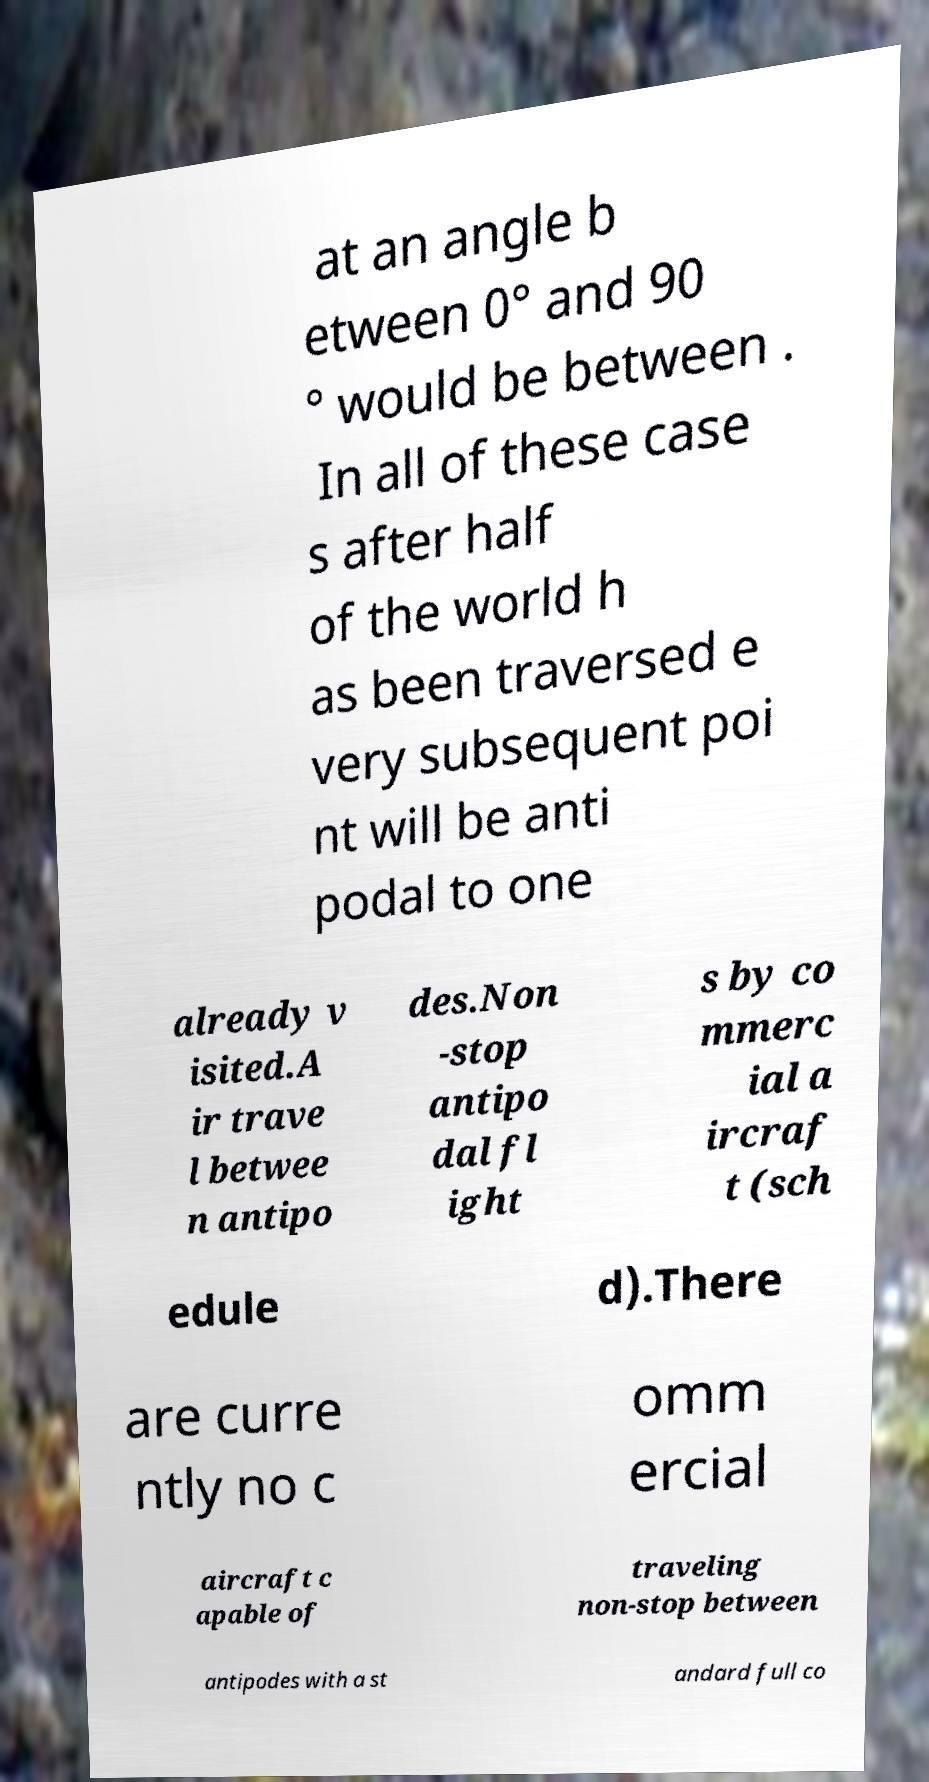Can you read and provide the text displayed in the image?This photo seems to have some interesting text. Can you extract and type it out for me? at an angle b etween 0° and 90 ° would be between . In all of these case s after half of the world h as been traversed e very subsequent poi nt will be anti podal to one already v isited.A ir trave l betwee n antipo des.Non -stop antipo dal fl ight s by co mmerc ial a ircraf t (sch edule d).There are curre ntly no c omm ercial aircraft c apable of traveling non-stop between antipodes with a st andard full co 